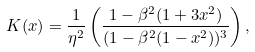<formula> <loc_0><loc_0><loc_500><loc_500>K ( x ) = \frac { 1 } { \eta ^ { 2 } } \left ( \frac { 1 - \beta ^ { 2 } ( 1 + 3 x ^ { 2 } ) } { ( 1 - \beta ^ { 2 } ( 1 - x ^ { 2 } ) ) ^ { 3 } } \right ) ,</formula> 